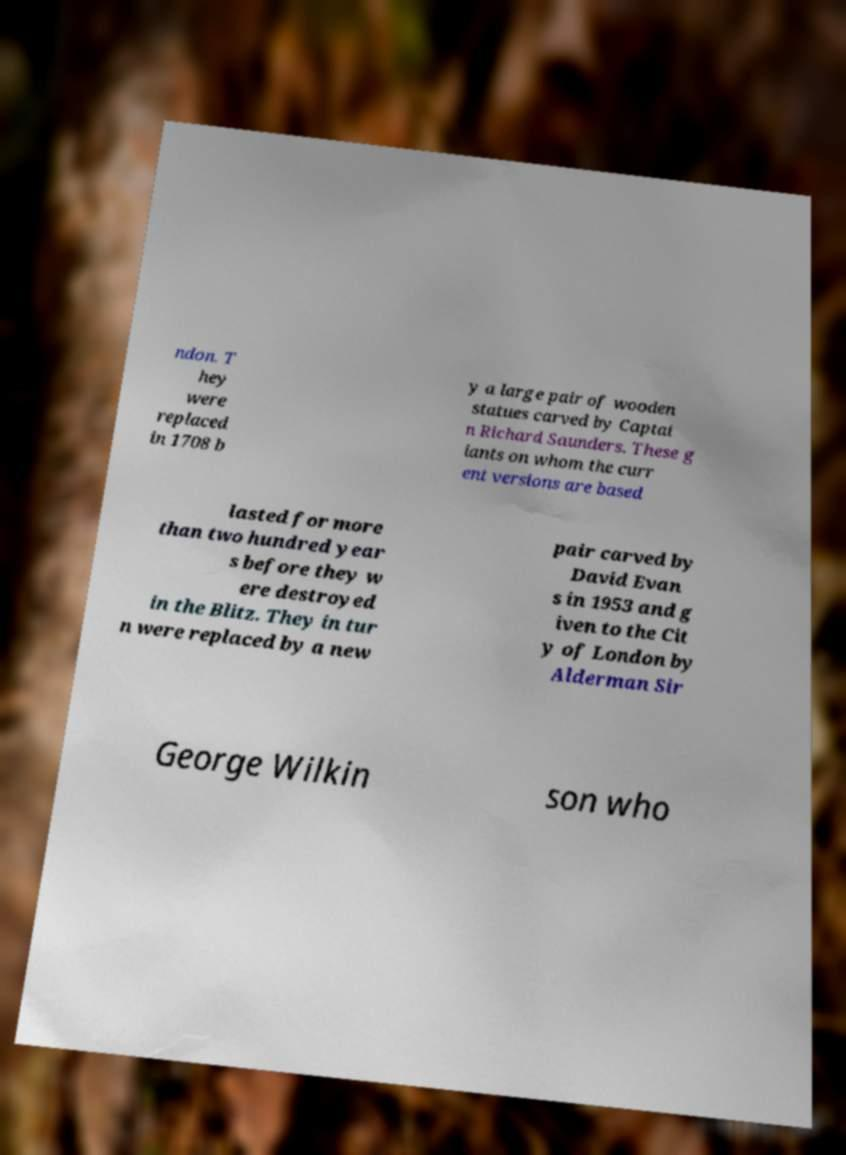Could you assist in decoding the text presented in this image and type it out clearly? ndon. T hey were replaced in 1708 b y a large pair of wooden statues carved by Captai n Richard Saunders. These g iants on whom the curr ent versions are based lasted for more than two hundred year s before they w ere destroyed in the Blitz. They in tur n were replaced by a new pair carved by David Evan s in 1953 and g iven to the Cit y of London by Alderman Sir George Wilkin son who 